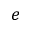Convert formula to latex. <formula><loc_0><loc_0><loc_500><loc_500>e</formula> 